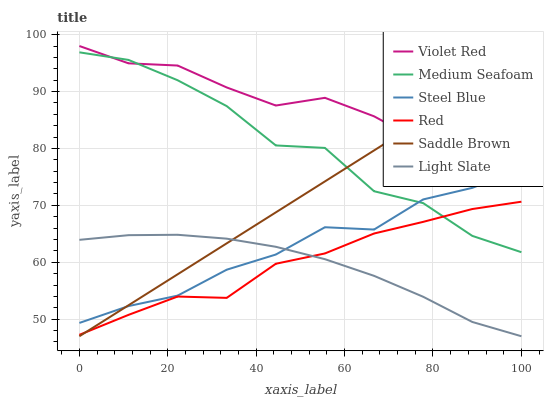Does Light Slate have the minimum area under the curve?
Answer yes or no. Yes. Does Violet Red have the maximum area under the curve?
Answer yes or no. Yes. Does Steel Blue have the minimum area under the curve?
Answer yes or no. No. Does Steel Blue have the maximum area under the curve?
Answer yes or no. No. Is Saddle Brown the smoothest?
Answer yes or no. Yes. Is Medium Seafoam the roughest?
Answer yes or no. Yes. Is Light Slate the smoothest?
Answer yes or no. No. Is Light Slate the roughest?
Answer yes or no. No. Does Light Slate have the lowest value?
Answer yes or no. Yes. Does Steel Blue have the lowest value?
Answer yes or no. No. Does Violet Red have the highest value?
Answer yes or no. Yes. Does Steel Blue have the highest value?
Answer yes or no. No. Is Red less than Steel Blue?
Answer yes or no. Yes. Is Medium Seafoam greater than Light Slate?
Answer yes or no. Yes. Does Medium Seafoam intersect Red?
Answer yes or no. Yes. Is Medium Seafoam less than Red?
Answer yes or no. No. Is Medium Seafoam greater than Red?
Answer yes or no. No. Does Red intersect Steel Blue?
Answer yes or no. No. 